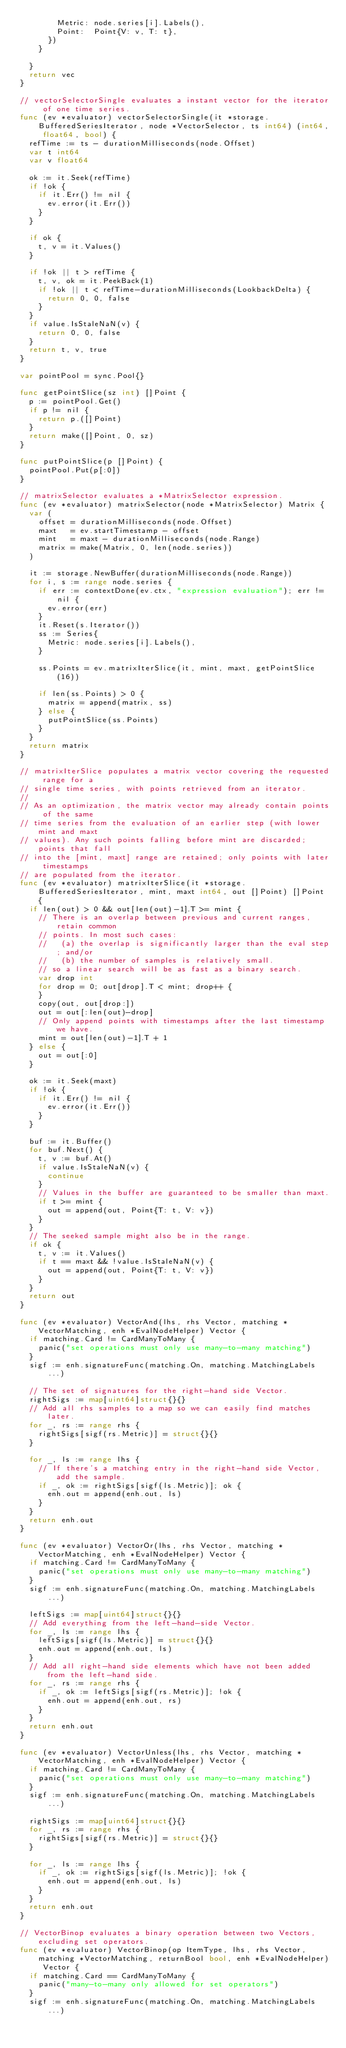<code> <loc_0><loc_0><loc_500><loc_500><_Go_>				Metric: node.series[i].Labels(),
				Point:  Point{V: v, T: t},
			})
		}

	}
	return vec
}

// vectorSelectorSingle evaluates a instant vector for the iterator of one time series.
func (ev *evaluator) vectorSelectorSingle(it *storage.BufferedSeriesIterator, node *VectorSelector, ts int64) (int64, float64, bool) {
	refTime := ts - durationMilliseconds(node.Offset)
	var t int64
	var v float64

	ok := it.Seek(refTime)
	if !ok {
		if it.Err() != nil {
			ev.error(it.Err())
		}
	}

	if ok {
		t, v = it.Values()
	}

	if !ok || t > refTime {
		t, v, ok = it.PeekBack(1)
		if !ok || t < refTime-durationMilliseconds(LookbackDelta) {
			return 0, 0, false
		}
	}
	if value.IsStaleNaN(v) {
		return 0, 0, false
	}
	return t, v, true
}

var pointPool = sync.Pool{}

func getPointSlice(sz int) []Point {
	p := pointPool.Get()
	if p != nil {
		return p.([]Point)
	}
	return make([]Point, 0, sz)
}

func putPointSlice(p []Point) {
	pointPool.Put(p[:0])
}

// matrixSelector evaluates a *MatrixSelector expression.
func (ev *evaluator) matrixSelector(node *MatrixSelector) Matrix {
	var (
		offset = durationMilliseconds(node.Offset)
		maxt   = ev.startTimestamp - offset
		mint   = maxt - durationMilliseconds(node.Range)
		matrix = make(Matrix, 0, len(node.series))
	)

	it := storage.NewBuffer(durationMilliseconds(node.Range))
	for i, s := range node.series {
		if err := contextDone(ev.ctx, "expression evaluation"); err != nil {
			ev.error(err)
		}
		it.Reset(s.Iterator())
		ss := Series{
			Metric: node.series[i].Labels(),
		}

		ss.Points = ev.matrixIterSlice(it, mint, maxt, getPointSlice(16))

		if len(ss.Points) > 0 {
			matrix = append(matrix, ss)
		} else {
			putPointSlice(ss.Points)
		}
	}
	return matrix
}

// matrixIterSlice populates a matrix vector covering the requested range for a
// single time series, with points retrieved from an iterator.
//
// As an optimization, the matrix vector may already contain points of the same
// time series from the evaluation of an earlier step (with lower mint and maxt
// values). Any such points falling before mint are discarded; points that fall
// into the [mint, maxt] range are retained; only points with later timestamps
// are populated from the iterator.
func (ev *evaluator) matrixIterSlice(it *storage.BufferedSeriesIterator, mint, maxt int64, out []Point) []Point {
	if len(out) > 0 && out[len(out)-1].T >= mint {
		// There is an overlap between previous and current ranges, retain common
		// points. In most such cases:
		//   (a) the overlap is significantly larger than the eval step; and/or
		//   (b) the number of samples is relatively small.
		// so a linear search will be as fast as a binary search.
		var drop int
		for drop = 0; out[drop].T < mint; drop++ {
		}
		copy(out, out[drop:])
		out = out[:len(out)-drop]
		// Only append points with timestamps after the last timestamp we have.
		mint = out[len(out)-1].T + 1
	} else {
		out = out[:0]
	}

	ok := it.Seek(maxt)
	if !ok {
		if it.Err() != nil {
			ev.error(it.Err())
		}
	}

	buf := it.Buffer()
	for buf.Next() {
		t, v := buf.At()
		if value.IsStaleNaN(v) {
			continue
		}
		// Values in the buffer are guaranteed to be smaller than maxt.
		if t >= mint {
			out = append(out, Point{T: t, V: v})
		}
	}
	// The seeked sample might also be in the range.
	if ok {
		t, v := it.Values()
		if t == maxt && !value.IsStaleNaN(v) {
			out = append(out, Point{T: t, V: v})
		}
	}
	return out
}

func (ev *evaluator) VectorAnd(lhs, rhs Vector, matching *VectorMatching, enh *EvalNodeHelper) Vector {
	if matching.Card != CardManyToMany {
		panic("set operations must only use many-to-many matching")
	}
	sigf := enh.signatureFunc(matching.On, matching.MatchingLabels...)

	// The set of signatures for the right-hand side Vector.
	rightSigs := map[uint64]struct{}{}
	// Add all rhs samples to a map so we can easily find matches later.
	for _, rs := range rhs {
		rightSigs[sigf(rs.Metric)] = struct{}{}
	}

	for _, ls := range lhs {
		// If there's a matching entry in the right-hand side Vector, add the sample.
		if _, ok := rightSigs[sigf(ls.Metric)]; ok {
			enh.out = append(enh.out, ls)
		}
	}
	return enh.out
}

func (ev *evaluator) VectorOr(lhs, rhs Vector, matching *VectorMatching, enh *EvalNodeHelper) Vector {
	if matching.Card != CardManyToMany {
		panic("set operations must only use many-to-many matching")
	}
	sigf := enh.signatureFunc(matching.On, matching.MatchingLabels...)

	leftSigs := map[uint64]struct{}{}
	// Add everything from the left-hand-side Vector.
	for _, ls := range lhs {
		leftSigs[sigf(ls.Metric)] = struct{}{}
		enh.out = append(enh.out, ls)
	}
	// Add all right-hand side elements which have not been added from the left-hand side.
	for _, rs := range rhs {
		if _, ok := leftSigs[sigf(rs.Metric)]; !ok {
			enh.out = append(enh.out, rs)
		}
	}
	return enh.out
}

func (ev *evaluator) VectorUnless(lhs, rhs Vector, matching *VectorMatching, enh *EvalNodeHelper) Vector {
	if matching.Card != CardManyToMany {
		panic("set operations must only use many-to-many matching")
	}
	sigf := enh.signatureFunc(matching.On, matching.MatchingLabels...)

	rightSigs := map[uint64]struct{}{}
	for _, rs := range rhs {
		rightSigs[sigf(rs.Metric)] = struct{}{}
	}

	for _, ls := range lhs {
		if _, ok := rightSigs[sigf(ls.Metric)]; !ok {
			enh.out = append(enh.out, ls)
		}
	}
	return enh.out
}

// VectorBinop evaluates a binary operation between two Vectors, excluding set operators.
func (ev *evaluator) VectorBinop(op ItemType, lhs, rhs Vector, matching *VectorMatching, returnBool bool, enh *EvalNodeHelper) Vector {
	if matching.Card == CardManyToMany {
		panic("many-to-many only allowed for set operators")
	}
	sigf := enh.signatureFunc(matching.On, matching.MatchingLabels...)
</code> 